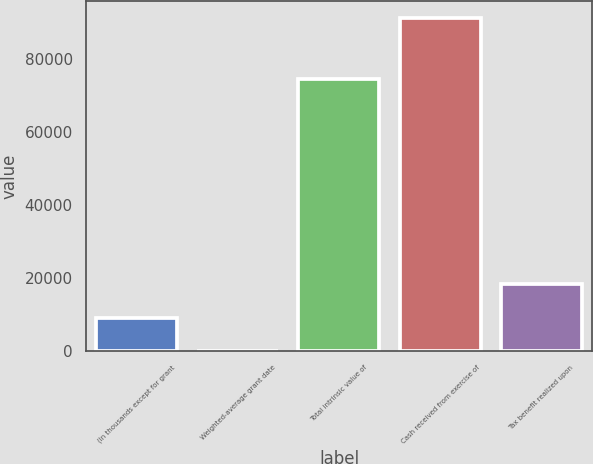Convert chart to OTSL. <chart><loc_0><loc_0><loc_500><loc_500><bar_chart><fcel>(In thousands except for grant<fcel>Weighted-average grant date<fcel>Total intrinsic value of<fcel>Cash received from exercise of<fcel>Tax benefit realized upon<nl><fcel>9153.02<fcel>20.13<fcel>74530<fcel>91349<fcel>18285.9<nl></chart> 